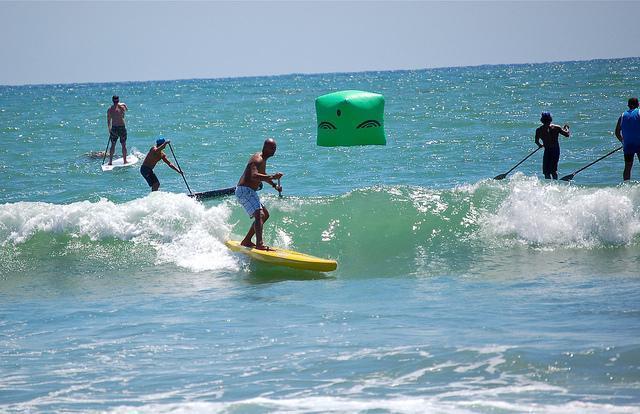How many people are on the water?
Give a very brief answer. 5. How many sailboats are shown?
Give a very brief answer. 0. How many cups can you see?
Give a very brief answer. 0. 